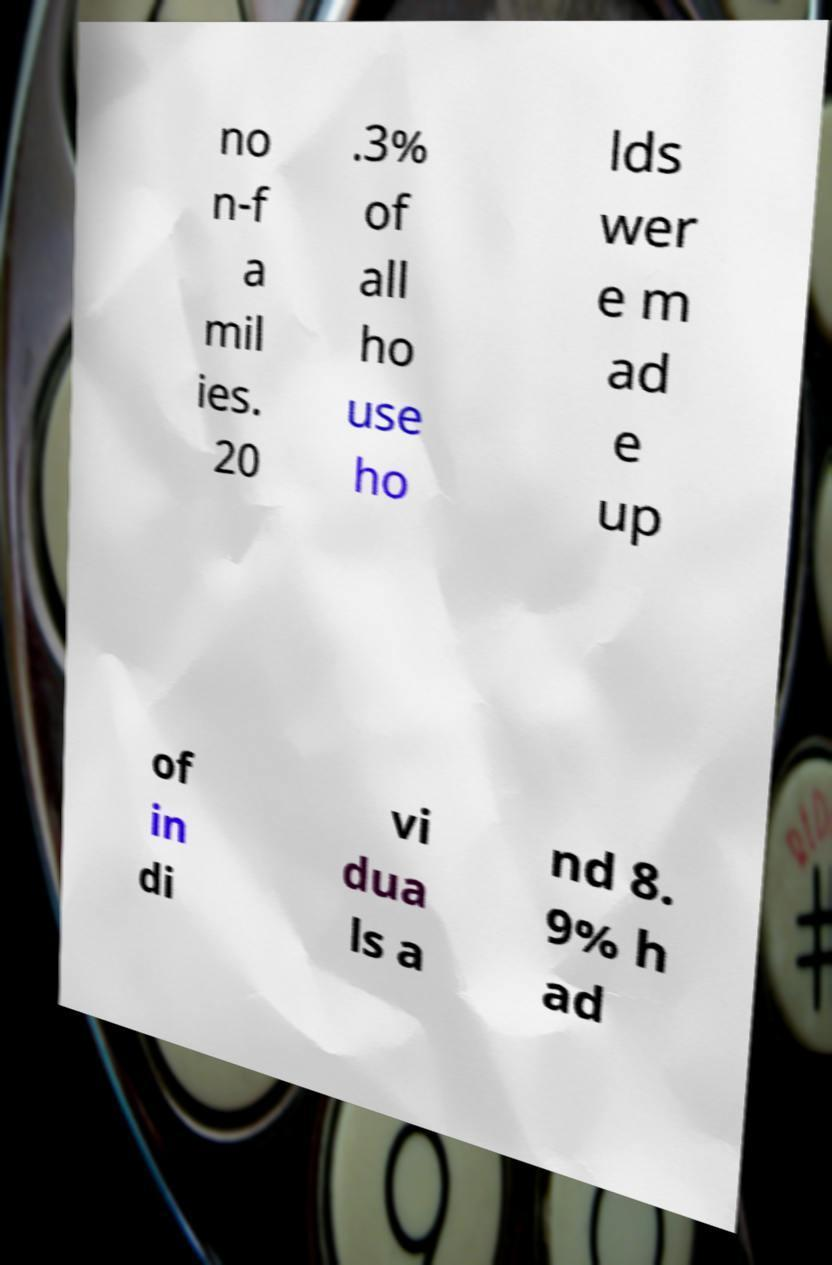Can you accurately transcribe the text from the provided image for me? no n-f a mil ies. 20 .3% of all ho use ho lds wer e m ad e up of in di vi dua ls a nd 8. 9% h ad 